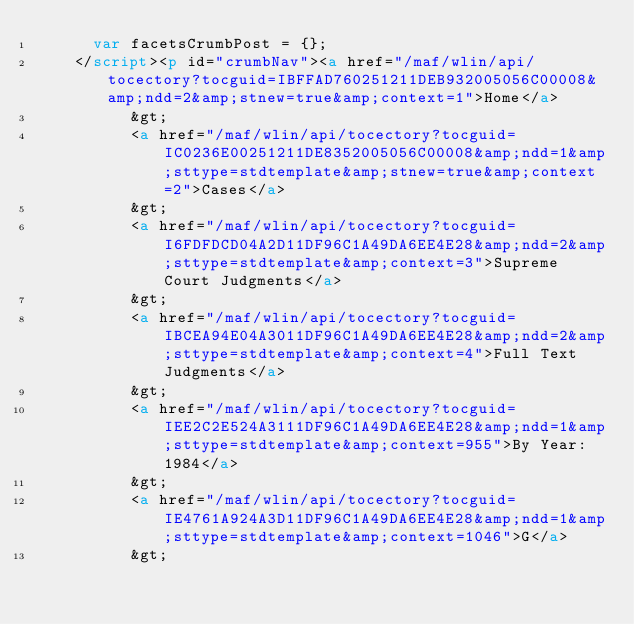Convert code to text. <code><loc_0><loc_0><loc_500><loc_500><_HTML_>			var facetsCrumbPost = {};
		</script><p id="crumbNav"><a href="/maf/wlin/api/tocectory?tocguid=IBFFAD760251211DEB932005056C00008&amp;ndd=2&amp;stnew=true&amp;context=1">Home</a>
				 	&gt;
					<a href="/maf/wlin/api/tocectory?tocguid=IC0236E00251211DE8352005056C00008&amp;ndd=1&amp;sttype=stdtemplate&amp;stnew=true&amp;context=2">Cases</a>
				 	&gt;
					<a href="/maf/wlin/api/tocectory?tocguid=I6FDFDCD04A2D11DF96C1A49DA6EE4E28&amp;ndd=2&amp;sttype=stdtemplate&amp;context=3">Supreme Court Judgments</a>
				 	&gt;
					<a href="/maf/wlin/api/tocectory?tocguid=IBCEA94E04A3011DF96C1A49DA6EE4E28&amp;ndd=2&amp;sttype=stdtemplate&amp;context=4">Full Text Judgments</a>
				 	&gt;
					<a href="/maf/wlin/api/tocectory?tocguid=IEE2C2E524A3111DF96C1A49DA6EE4E28&amp;ndd=1&amp;sttype=stdtemplate&amp;context=955">By Year: 1984</a>
				 	&gt;
					<a href="/maf/wlin/api/tocectory?tocguid=IE4761A924A3D11DF96C1A49DA6EE4E28&amp;ndd=1&amp;sttype=stdtemplate&amp;context=1046">G</a>
				 	&gt;</code> 